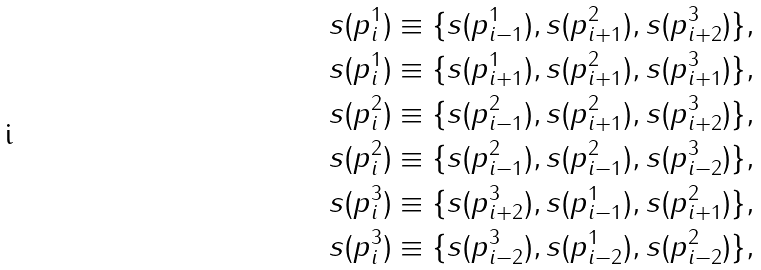<formula> <loc_0><loc_0><loc_500><loc_500>s ( p ^ { 1 } _ { i } ) & \equiv \{ s ( p ^ { 1 } _ { i - 1 } ) , s ( p ^ { 2 } _ { i + 1 } ) , s ( p ^ { 3 } _ { i + 2 } ) \} , \\ s ( p ^ { 1 } _ { i } ) & \equiv \{ s ( p ^ { 1 } _ { i + 1 } ) , s ( p ^ { 2 } _ { i + 1 } ) , s ( p ^ { 3 } _ { i + 1 } ) \} , \\ s ( p ^ { 2 } _ { i } ) & \equiv \{ s ( p ^ { 2 } _ { i - 1 } ) , s ( p ^ { 2 } _ { i + 1 } ) , s ( p ^ { 3 } _ { i + 2 } ) \} , \\ s ( p ^ { 2 } _ { i } ) & \equiv \{ s ( p ^ { 2 } _ { i - 1 } ) , s ( p ^ { 2 } _ { i - 1 } ) , s ( p ^ { 3 } _ { i - 2 } ) \} , \\ s ( p ^ { 3 } _ { i } ) & \equiv \{ s ( p ^ { 3 } _ { i + 2 } ) , s ( p ^ { 1 } _ { i - 1 } ) , s ( p ^ { 2 } _ { i + 1 } ) \} , \\ s ( p ^ { 3 } _ { i } ) & \equiv \{ s ( p ^ { 3 } _ { i - 2 } ) , s ( p ^ { 1 } _ { i - 2 } ) , s ( p ^ { 2 } _ { i - 2 } ) \} ,</formula> 